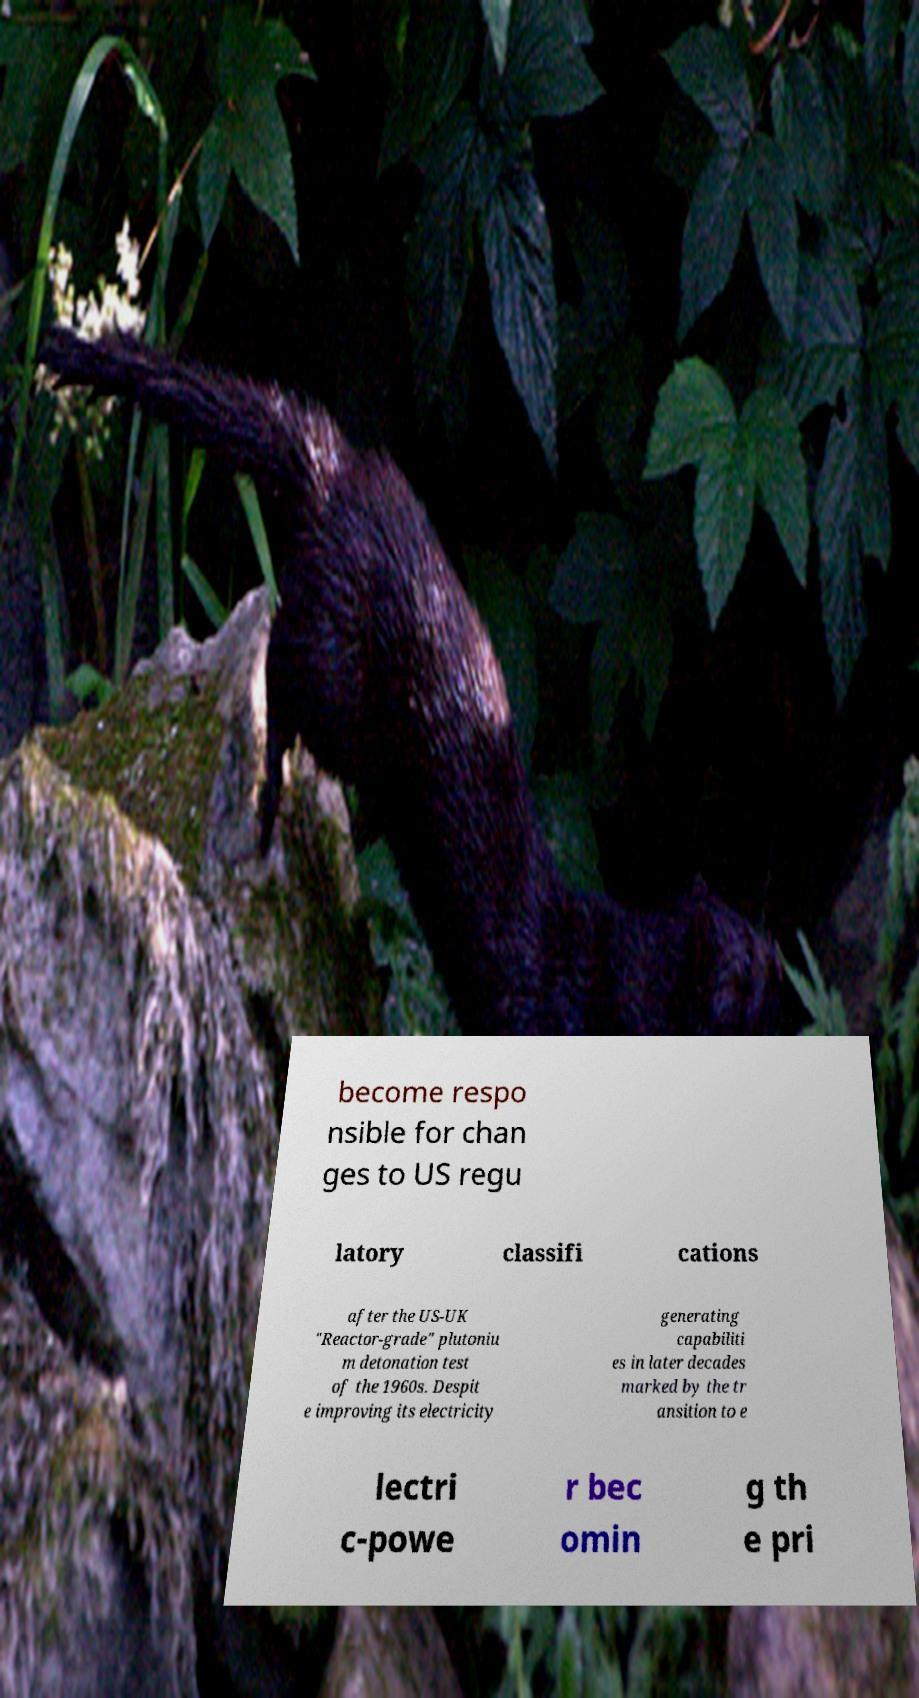Please read and relay the text visible in this image. What does it say? become respo nsible for chan ges to US regu latory classifi cations after the US-UK "Reactor-grade" plutoniu m detonation test of the 1960s. Despit e improving its electricity generating capabiliti es in later decades marked by the tr ansition to e lectri c-powe r bec omin g th e pri 